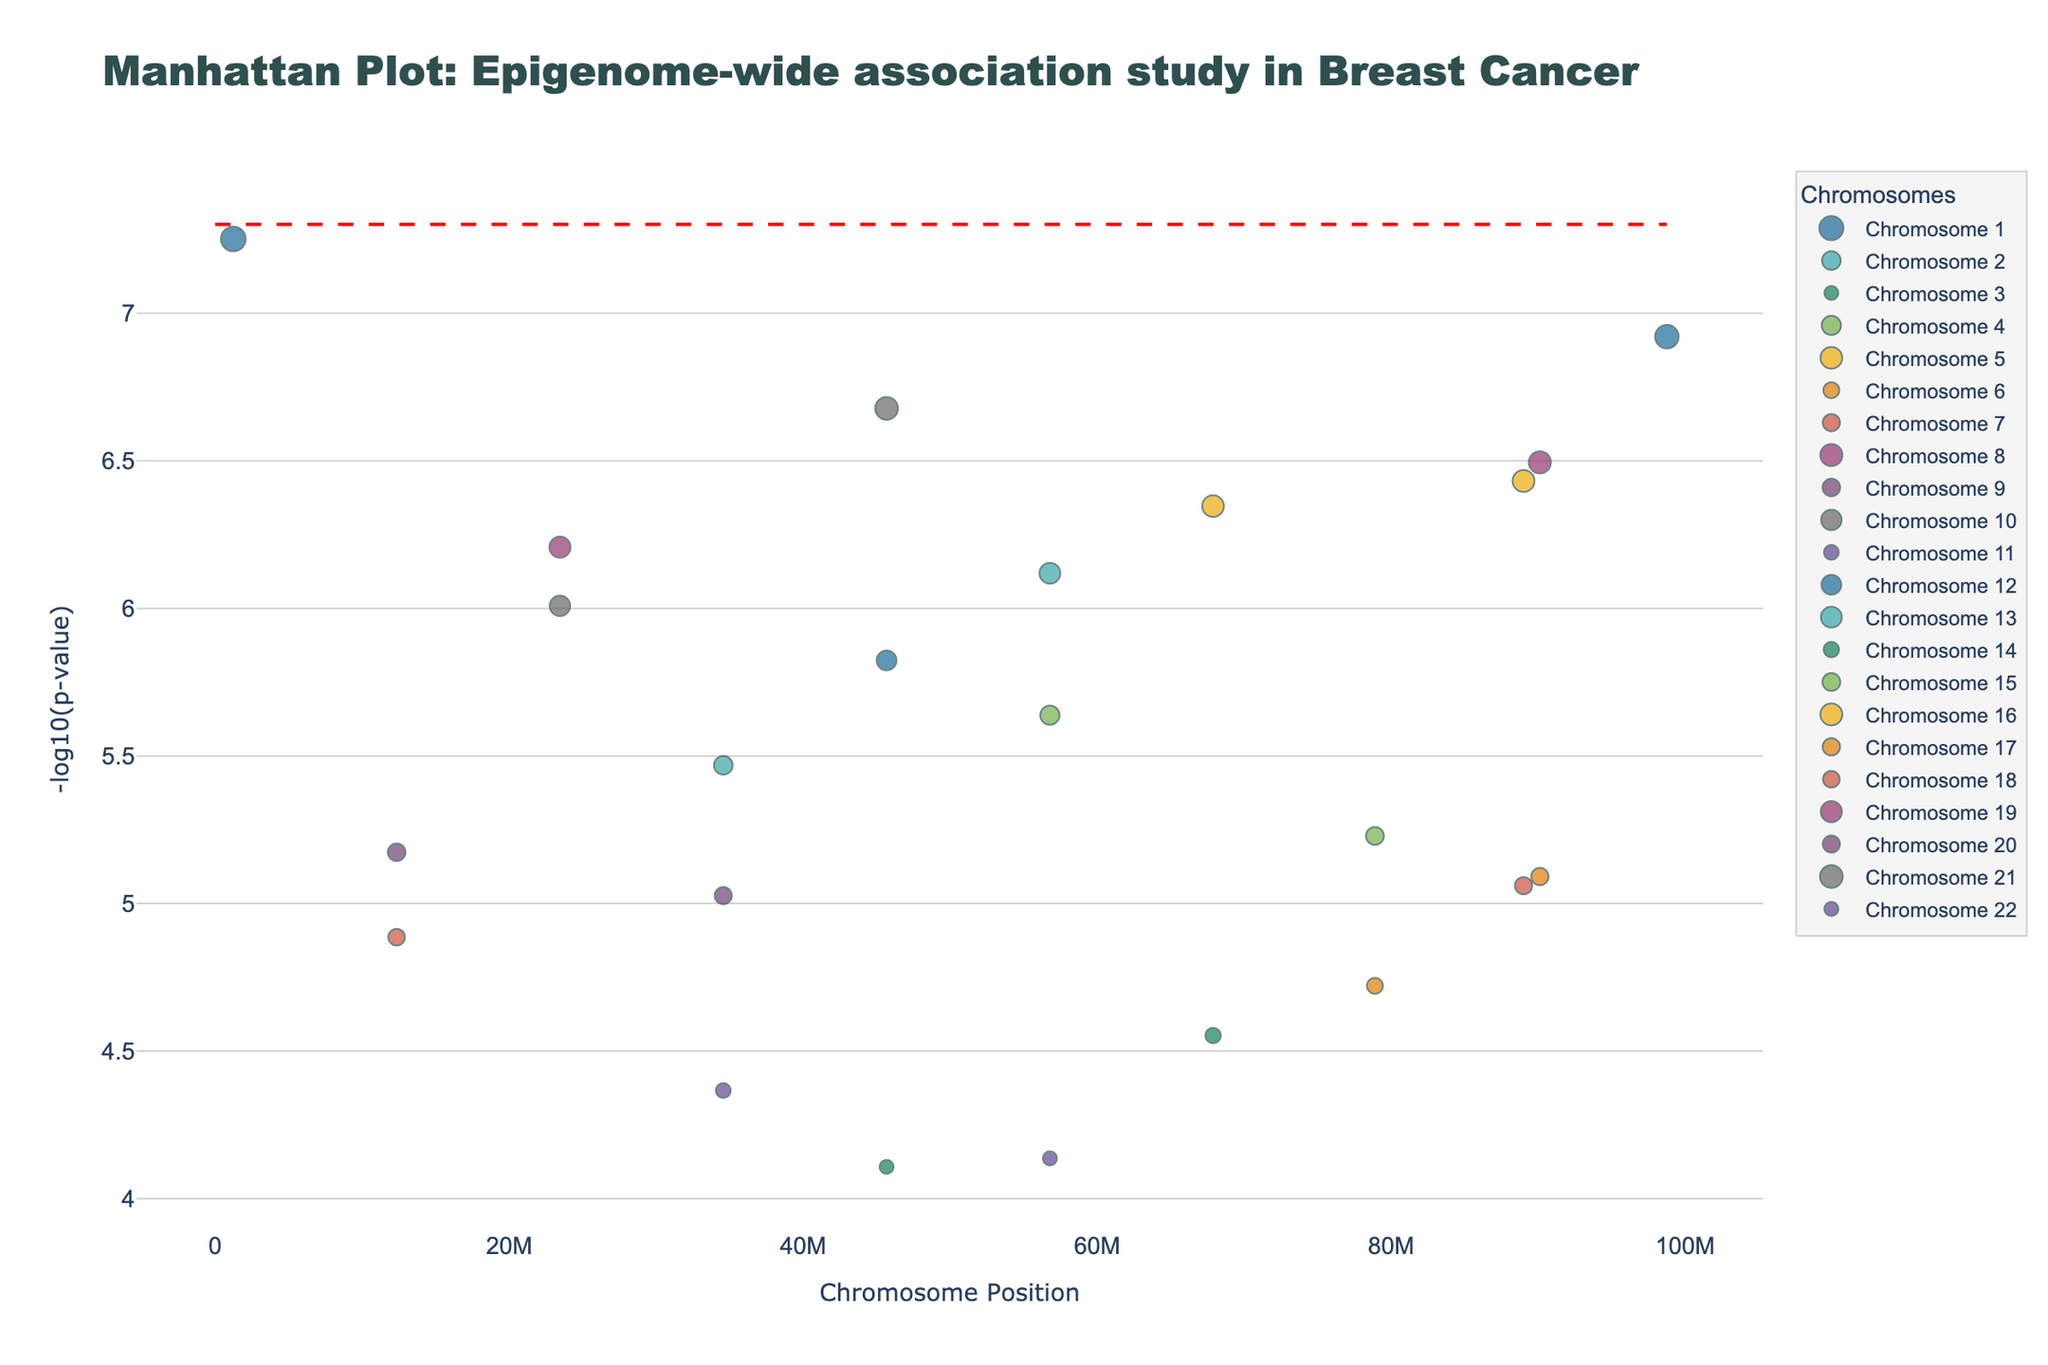What is the title of the plot? The title of the plot is prominently displayed at the top and usually gives an overview of what the plot represents. In this case, the title is "Manhattan Plot: Epigenome-wide association study in Breast Cancer".
Answer: Manhattan Plot: Epigenome-wide association study in Breast Cancer What does the y-axis represent? The y-axis typically shows the dependent variable in the plot. Here, it is labeled as "-log10(p-value)", indicating the negative log transformation of the p-values.
Answer: -log10(p-value) Which chromosome has the largest number of significant genes? By observing the clusters of points or density of markers for each chromosome, we identify that Chromosome 1 has the most data points under the significance threshold.
Answer: Chromosome 1 How many points are above the red significance line? Visually count all the points that are positioned above the horizontal red dashed line, representing the significance threshold (−log10(5e-8)). There are 2 points.
Answer: 2 Which gene has the lowest p-value and on which chromosome is it located? By looking at the highest point on the y-axis, which corresponds to the lowest p-value, we find that the gene is BRCA1 on Chromosome 1.
Answer: BRCA1 on Chromosome 1 Compare the p-values of BRCA1 and TP53. Which gene has a more significant association with breast cancer? BRCA1 has a smaller p-value and therefore appears higher on the y-axis compared to TP53. This indicates a more significant association.
Answer: BRCA1 What is the x-axis representing in this plot? The x-axis typically represents the independent variable. Here, it is labeled as "Chromosome Position", showing the genomic location on each chromosome.
Answer: Chromosome Position Which genes are annotated as notable below the red significance line but close to it? Check among the points closest to but below the red line. The genes BRCA2, PALB2, and TERT are notable.
Answer: BRCA2, PALB2, and TERT Between TERT and CASP8 on the y-axis, which gene is positioned higher and what does that imply? A higher position on the y-axis (-log10(p-value)) means a lower p-value, which implies stronger statistical significance. TERT is positioned higher, indicating a stronger association with breast cancer than CASP8.
Answer: TERT 